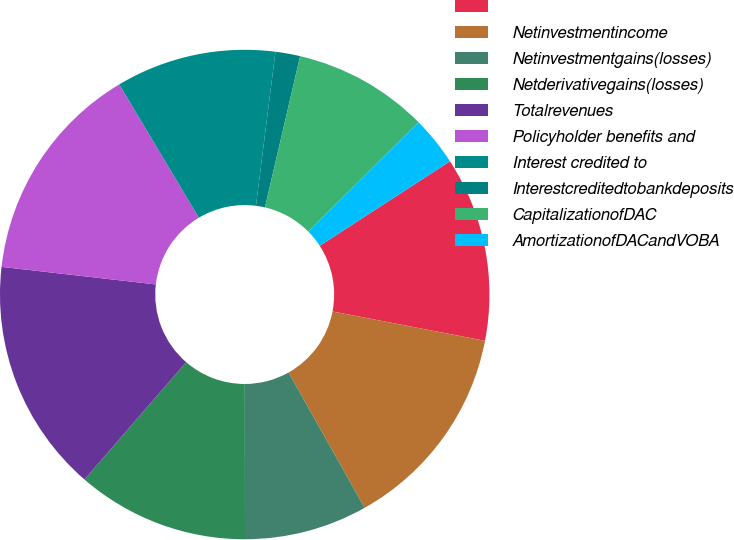<chart> <loc_0><loc_0><loc_500><loc_500><pie_chart><ecel><fcel>Netinvestmentincome<fcel>Netinvestmentgains(losses)<fcel>Netderivativegains(losses)<fcel>Totalrevenues<fcel>Policyholder benefits and<fcel>Interest credited to<fcel>Interestcreditedtobankdeposits<fcel>CapitalizationofDAC<fcel>AmortizationofDACandVOBA<nl><fcel>12.19%<fcel>13.82%<fcel>8.13%<fcel>11.38%<fcel>15.44%<fcel>14.63%<fcel>10.57%<fcel>1.63%<fcel>8.94%<fcel>3.26%<nl></chart> 